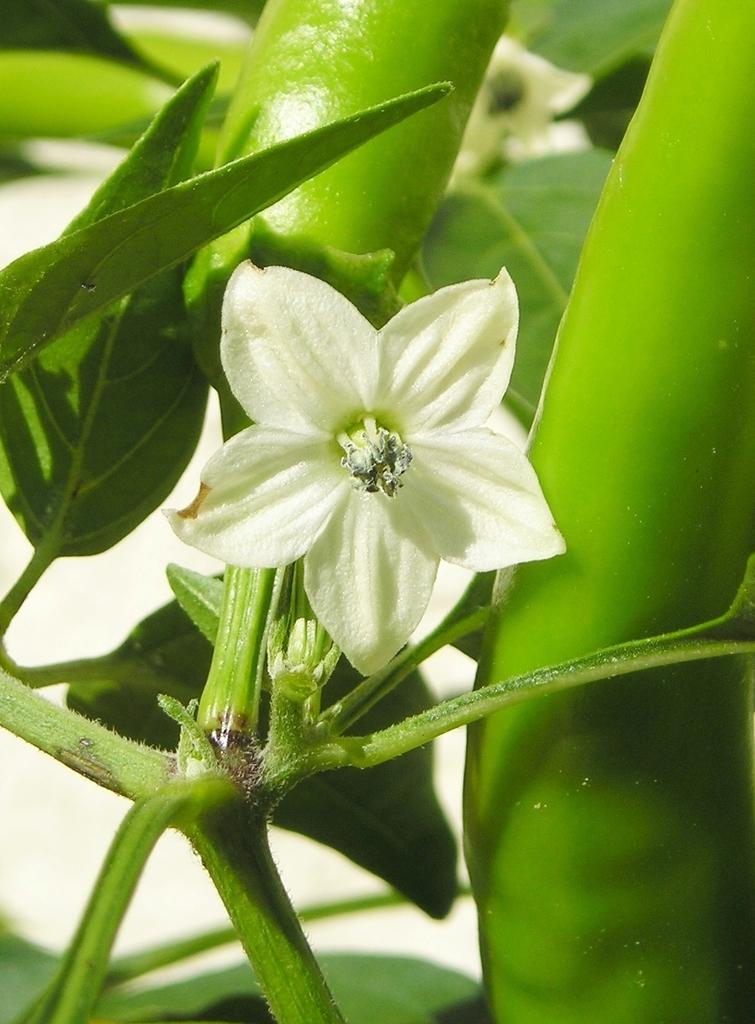What type of plant is in the image? There is a plant in the image. What color is the flower on the plant? The plant has a white flower. What else is present on the plant besides the flower? The plant has green chilies. What type of stamp can be seen on the chilies in the image? There is no stamp present on the chilies in the image. 